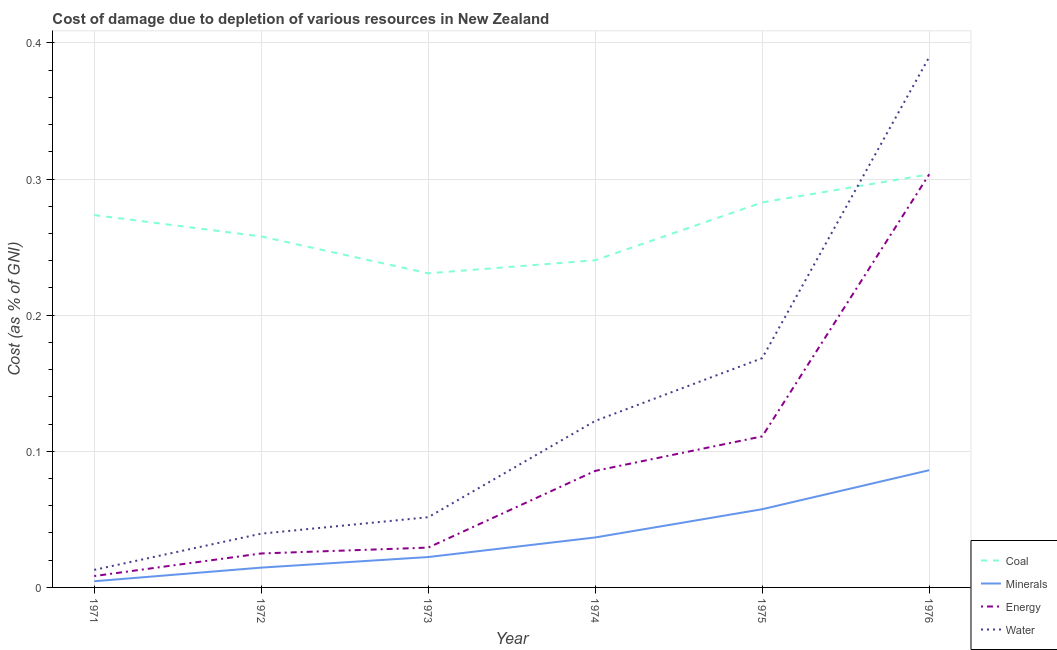Does the line corresponding to cost of damage due to depletion of coal intersect with the line corresponding to cost of damage due to depletion of minerals?
Give a very brief answer. No. Is the number of lines equal to the number of legend labels?
Give a very brief answer. Yes. What is the cost of damage due to depletion of minerals in 1975?
Ensure brevity in your answer.  0.06. Across all years, what is the maximum cost of damage due to depletion of minerals?
Your answer should be very brief. 0.09. Across all years, what is the minimum cost of damage due to depletion of coal?
Provide a short and direct response. 0.23. In which year was the cost of damage due to depletion of minerals maximum?
Keep it short and to the point. 1976. What is the total cost of damage due to depletion of energy in the graph?
Make the answer very short. 0.56. What is the difference between the cost of damage due to depletion of minerals in 1972 and that in 1974?
Your response must be concise. -0.02. What is the difference between the cost of damage due to depletion of water in 1976 and the cost of damage due to depletion of energy in 1972?
Provide a short and direct response. 0.36. What is the average cost of damage due to depletion of energy per year?
Ensure brevity in your answer.  0.09. In the year 1971, what is the difference between the cost of damage due to depletion of coal and cost of damage due to depletion of minerals?
Give a very brief answer. 0.27. In how many years, is the cost of damage due to depletion of water greater than 0.04 %?
Give a very brief answer. 4. What is the ratio of the cost of damage due to depletion of energy in 1974 to that in 1975?
Keep it short and to the point. 0.77. What is the difference between the highest and the second highest cost of damage due to depletion of energy?
Provide a short and direct response. 0.19. What is the difference between the highest and the lowest cost of damage due to depletion of water?
Offer a terse response. 0.38. Is it the case that in every year, the sum of the cost of damage due to depletion of minerals and cost of damage due to depletion of water is greater than the sum of cost of damage due to depletion of coal and cost of damage due to depletion of energy?
Offer a very short reply. No. Is the cost of damage due to depletion of minerals strictly less than the cost of damage due to depletion of coal over the years?
Your answer should be very brief. Yes. Are the values on the major ticks of Y-axis written in scientific E-notation?
Offer a very short reply. No. Does the graph contain any zero values?
Make the answer very short. No. How many legend labels are there?
Keep it short and to the point. 4. How are the legend labels stacked?
Offer a terse response. Vertical. What is the title of the graph?
Make the answer very short. Cost of damage due to depletion of various resources in New Zealand . What is the label or title of the Y-axis?
Ensure brevity in your answer.  Cost (as % of GNI). What is the Cost (as % of GNI) of Coal in 1971?
Provide a short and direct response. 0.27. What is the Cost (as % of GNI) in Minerals in 1971?
Offer a very short reply. 0. What is the Cost (as % of GNI) in Energy in 1971?
Give a very brief answer. 0.01. What is the Cost (as % of GNI) in Water in 1971?
Your answer should be very brief. 0.01. What is the Cost (as % of GNI) in Coal in 1972?
Your answer should be compact. 0.26. What is the Cost (as % of GNI) of Minerals in 1972?
Your answer should be compact. 0.01. What is the Cost (as % of GNI) of Energy in 1972?
Keep it short and to the point. 0.02. What is the Cost (as % of GNI) in Water in 1972?
Your answer should be very brief. 0.04. What is the Cost (as % of GNI) in Coal in 1973?
Your answer should be compact. 0.23. What is the Cost (as % of GNI) in Minerals in 1973?
Give a very brief answer. 0.02. What is the Cost (as % of GNI) in Energy in 1973?
Make the answer very short. 0.03. What is the Cost (as % of GNI) in Water in 1973?
Offer a very short reply. 0.05. What is the Cost (as % of GNI) in Coal in 1974?
Provide a short and direct response. 0.24. What is the Cost (as % of GNI) of Minerals in 1974?
Offer a terse response. 0.04. What is the Cost (as % of GNI) of Energy in 1974?
Make the answer very short. 0.09. What is the Cost (as % of GNI) in Water in 1974?
Ensure brevity in your answer.  0.12. What is the Cost (as % of GNI) in Coal in 1975?
Give a very brief answer. 0.28. What is the Cost (as % of GNI) of Minerals in 1975?
Give a very brief answer. 0.06. What is the Cost (as % of GNI) of Energy in 1975?
Give a very brief answer. 0.11. What is the Cost (as % of GNI) in Water in 1975?
Keep it short and to the point. 0.17. What is the Cost (as % of GNI) of Coal in 1976?
Provide a short and direct response. 0.3. What is the Cost (as % of GNI) of Minerals in 1976?
Your answer should be very brief. 0.09. What is the Cost (as % of GNI) in Energy in 1976?
Offer a very short reply. 0.3. What is the Cost (as % of GNI) in Water in 1976?
Your answer should be very brief. 0.39. Across all years, what is the maximum Cost (as % of GNI) of Coal?
Make the answer very short. 0.3. Across all years, what is the maximum Cost (as % of GNI) in Minerals?
Provide a short and direct response. 0.09. Across all years, what is the maximum Cost (as % of GNI) of Energy?
Make the answer very short. 0.3. Across all years, what is the maximum Cost (as % of GNI) of Water?
Offer a very short reply. 0.39. Across all years, what is the minimum Cost (as % of GNI) in Coal?
Provide a short and direct response. 0.23. Across all years, what is the minimum Cost (as % of GNI) of Minerals?
Offer a terse response. 0. Across all years, what is the minimum Cost (as % of GNI) in Energy?
Keep it short and to the point. 0.01. Across all years, what is the minimum Cost (as % of GNI) of Water?
Provide a succinct answer. 0.01. What is the total Cost (as % of GNI) of Coal in the graph?
Provide a short and direct response. 1.59. What is the total Cost (as % of GNI) in Minerals in the graph?
Give a very brief answer. 0.22. What is the total Cost (as % of GNI) in Energy in the graph?
Provide a succinct answer. 0.56. What is the total Cost (as % of GNI) of Water in the graph?
Offer a terse response. 0.78. What is the difference between the Cost (as % of GNI) in Coal in 1971 and that in 1972?
Offer a very short reply. 0.02. What is the difference between the Cost (as % of GNI) in Minerals in 1971 and that in 1972?
Your answer should be very brief. -0.01. What is the difference between the Cost (as % of GNI) in Energy in 1971 and that in 1972?
Keep it short and to the point. -0.02. What is the difference between the Cost (as % of GNI) of Water in 1971 and that in 1972?
Your response must be concise. -0.03. What is the difference between the Cost (as % of GNI) in Coal in 1971 and that in 1973?
Offer a terse response. 0.04. What is the difference between the Cost (as % of GNI) in Minerals in 1971 and that in 1973?
Make the answer very short. -0.02. What is the difference between the Cost (as % of GNI) in Energy in 1971 and that in 1973?
Offer a very short reply. -0.02. What is the difference between the Cost (as % of GNI) of Water in 1971 and that in 1973?
Offer a very short reply. -0.04. What is the difference between the Cost (as % of GNI) of Coal in 1971 and that in 1974?
Give a very brief answer. 0.03. What is the difference between the Cost (as % of GNI) in Minerals in 1971 and that in 1974?
Keep it short and to the point. -0.03. What is the difference between the Cost (as % of GNI) in Energy in 1971 and that in 1974?
Provide a short and direct response. -0.08. What is the difference between the Cost (as % of GNI) of Water in 1971 and that in 1974?
Provide a succinct answer. -0.11. What is the difference between the Cost (as % of GNI) of Coal in 1971 and that in 1975?
Keep it short and to the point. -0.01. What is the difference between the Cost (as % of GNI) of Minerals in 1971 and that in 1975?
Provide a short and direct response. -0.05. What is the difference between the Cost (as % of GNI) in Energy in 1971 and that in 1975?
Your answer should be very brief. -0.1. What is the difference between the Cost (as % of GNI) of Water in 1971 and that in 1975?
Provide a short and direct response. -0.16. What is the difference between the Cost (as % of GNI) in Coal in 1971 and that in 1976?
Make the answer very short. -0.03. What is the difference between the Cost (as % of GNI) of Minerals in 1971 and that in 1976?
Offer a terse response. -0.08. What is the difference between the Cost (as % of GNI) of Energy in 1971 and that in 1976?
Provide a short and direct response. -0.3. What is the difference between the Cost (as % of GNI) of Water in 1971 and that in 1976?
Give a very brief answer. -0.38. What is the difference between the Cost (as % of GNI) in Coal in 1972 and that in 1973?
Keep it short and to the point. 0.03. What is the difference between the Cost (as % of GNI) of Minerals in 1972 and that in 1973?
Your answer should be compact. -0.01. What is the difference between the Cost (as % of GNI) of Energy in 1972 and that in 1973?
Your response must be concise. -0. What is the difference between the Cost (as % of GNI) of Water in 1972 and that in 1973?
Ensure brevity in your answer.  -0.01. What is the difference between the Cost (as % of GNI) in Coal in 1972 and that in 1974?
Provide a succinct answer. 0.02. What is the difference between the Cost (as % of GNI) in Minerals in 1972 and that in 1974?
Your answer should be very brief. -0.02. What is the difference between the Cost (as % of GNI) in Energy in 1972 and that in 1974?
Your response must be concise. -0.06. What is the difference between the Cost (as % of GNI) in Water in 1972 and that in 1974?
Your answer should be very brief. -0.08. What is the difference between the Cost (as % of GNI) of Coal in 1972 and that in 1975?
Provide a succinct answer. -0.03. What is the difference between the Cost (as % of GNI) of Minerals in 1972 and that in 1975?
Make the answer very short. -0.04. What is the difference between the Cost (as % of GNI) in Energy in 1972 and that in 1975?
Give a very brief answer. -0.09. What is the difference between the Cost (as % of GNI) in Water in 1972 and that in 1975?
Make the answer very short. -0.13. What is the difference between the Cost (as % of GNI) in Coal in 1972 and that in 1976?
Your answer should be compact. -0.05. What is the difference between the Cost (as % of GNI) of Minerals in 1972 and that in 1976?
Offer a terse response. -0.07. What is the difference between the Cost (as % of GNI) in Energy in 1972 and that in 1976?
Make the answer very short. -0.28. What is the difference between the Cost (as % of GNI) of Water in 1972 and that in 1976?
Offer a very short reply. -0.35. What is the difference between the Cost (as % of GNI) in Coal in 1973 and that in 1974?
Your response must be concise. -0.01. What is the difference between the Cost (as % of GNI) of Minerals in 1973 and that in 1974?
Ensure brevity in your answer.  -0.01. What is the difference between the Cost (as % of GNI) of Energy in 1973 and that in 1974?
Your answer should be very brief. -0.06. What is the difference between the Cost (as % of GNI) of Water in 1973 and that in 1974?
Provide a succinct answer. -0.07. What is the difference between the Cost (as % of GNI) of Coal in 1973 and that in 1975?
Provide a short and direct response. -0.05. What is the difference between the Cost (as % of GNI) in Minerals in 1973 and that in 1975?
Ensure brevity in your answer.  -0.04. What is the difference between the Cost (as % of GNI) in Energy in 1973 and that in 1975?
Your answer should be compact. -0.08. What is the difference between the Cost (as % of GNI) in Water in 1973 and that in 1975?
Give a very brief answer. -0.12. What is the difference between the Cost (as % of GNI) in Coal in 1973 and that in 1976?
Make the answer very short. -0.07. What is the difference between the Cost (as % of GNI) of Minerals in 1973 and that in 1976?
Offer a very short reply. -0.06. What is the difference between the Cost (as % of GNI) in Energy in 1973 and that in 1976?
Give a very brief answer. -0.27. What is the difference between the Cost (as % of GNI) in Water in 1973 and that in 1976?
Offer a terse response. -0.34. What is the difference between the Cost (as % of GNI) in Coal in 1974 and that in 1975?
Offer a terse response. -0.04. What is the difference between the Cost (as % of GNI) in Minerals in 1974 and that in 1975?
Offer a very short reply. -0.02. What is the difference between the Cost (as % of GNI) of Energy in 1974 and that in 1975?
Your response must be concise. -0.03. What is the difference between the Cost (as % of GNI) of Water in 1974 and that in 1975?
Your response must be concise. -0.05. What is the difference between the Cost (as % of GNI) of Coal in 1974 and that in 1976?
Make the answer very short. -0.06. What is the difference between the Cost (as % of GNI) in Minerals in 1974 and that in 1976?
Give a very brief answer. -0.05. What is the difference between the Cost (as % of GNI) in Energy in 1974 and that in 1976?
Make the answer very short. -0.22. What is the difference between the Cost (as % of GNI) of Water in 1974 and that in 1976?
Provide a succinct answer. -0.27. What is the difference between the Cost (as % of GNI) of Coal in 1975 and that in 1976?
Provide a short and direct response. -0.02. What is the difference between the Cost (as % of GNI) of Minerals in 1975 and that in 1976?
Your response must be concise. -0.03. What is the difference between the Cost (as % of GNI) in Energy in 1975 and that in 1976?
Provide a succinct answer. -0.19. What is the difference between the Cost (as % of GNI) in Water in 1975 and that in 1976?
Provide a succinct answer. -0.22. What is the difference between the Cost (as % of GNI) in Coal in 1971 and the Cost (as % of GNI) in Minerals in 1972?
Your response must be concise. 0.26. What is the difference between the Cost (as % of GNI) of Coal in 1971 and the Cost (as % of GNI) of Energy in 1972?
Ensure brevity in your answer.  0.25. What is the difference between the Cost (as % of GNI) of Coal in 1971 and the Cost (as % of GNI) of Water in 1972?
Give a very brief answer. 0.23. What is the difference between the Cost (as % of GNI) of Minerals in 1971 and the Cost (as % of GNI) of Energy in 1972?
Provide a short and direct response. -0.02. What is the difference between the Cost (as % of GNI) of Minerals in 1971 and the Cost (as % of GNI) of Water in 1972?
Provide a short and direct response. -0.04. What is the difference between the Cost (as % of GNI) of Energy in 1971 and the Cost (as % of GNI) of Water in 1972?
Your response must be concise. -0.03. What is the difference between the Cost (as % of GNI) in Coal in 1971 and the Cost (as % of GNI) in Minerals in 1973?
Your answer should be compact. 0.25. What is the difference between the Cost (as % of GNI) of Coal in 1971 and the Cost (as % of GNI) of Energy in 1973?
Ensure brevity in your answer.  0.24. What is the difference between the Cost (as % of GNI) in Coal in 1971 and the Cost (as % of GNI) in Water in 1973?
Your answer should be very brief. 0.22. What is the difference between the Cost (as % of GNI) of Minerals in 1971 and the Cost (as % of GNI) of Energy in 1973?
Provide a short and direct response. -0.02. What is the difference between the Cost (as % of GNI) in Minerals in 1971 and the Cost (as % of GNI) in Water in 1973?
Your answer should be very brief. -0.05. What is the difference between the Cost (as % of GNI) in Energy in 1971 and the Cost (as % of GNI) in Water in 1973?
Provide a succinct answer. -0.04. What is the difference between the Cost (as % of GNI) of Coal in 1971 and the Cost (as % of GNI) of Minerals in 1974?
Offer a very short reply. 0.24. What is the difference between the Cost (as % of GNI) of Coal in 1971 and the Cost (as % of GNI) of Energy in 1974?
Offer a very short reply. 0.19. What is the difference between the Cost (as % of GNI) of Coal in 1971 and the Cost (as % of GNI) of Water in 1974?
Provide a short and direct response. 0.15. What is the difference between the Cost (as % of GNI) in Minerals in 1971 and the Cost (as % of GNI) in Energy in 1974?
Your answer should be very brief. -0.08. What is the difference between the Cost (as % of GNI) of Minerals in 1971 and the Cost (as % of GNI) of Water in 1974?
Your response must be concise. -0.12. What is the difference between the Cost (as % of GNI) of Energy in 1971 and the Cost (as % of GNI) of Water in 1974?
Give a very brief answer. -0.11. What is the difference between the Cost (as % of GNI) in Coal in 1971 and the Cost (as % of GNI) in Minerals in 1975?
Keep it short and to the point. 0.22. What is the difference between the Cost (as % of GNI) in Coal in 1971 and the Cost (as % of GNI) in Energy in 1975?
Your answer should be compact. 0.16. What is the difference between the Cost (as % of GNI) in Coal in 1971 and the Cost (as % of GNI) in Water in 1975?
Provide a short and direct response. 0.11. What is the difference between the Cost (as % of GNI) of Minerals in 1971 and the Cost (as % of GNI) of Energy in 1975?
Keep it short and to the point. -0.11. What is the difference between the Cost (as % of GNI) in Minerals in 1971 and the Cost (as % of GNI) in Water in 1975?
Offer a terse response. -0.16. What is the difference between the Cost (as % of GNI) in Energy in 1971 and the Cost (as % of GNI) in Water in 1975?
Provide a succinct answer. -0.16. What is the difference between the Cost (as % of GNI) of Coal in 1971 and the Cost (as % of GNI) of Minerals in 1976?
Ensure brevity in your answer.  0.19. What is the difference between the Cost (as % of GNI) in Coal in 1971 and the Cost (as % of GNI) in Energy in 1976?
Ensure brevity in your answer.  -0.03. What is the difference between the Cost (as % of GNI) of Coal in 1971 and the Cost (as % of GNI) of Water in 1976?
Provide a succinct answer. -0.12. What is the difference between the Cost (as % of GNI) of Minerals in 1971 and the Cost (as % of GNI) of Energy in 1976?
Your answer should be compact. -0.3. What is the difference between the Cost (as % of GNI) in Minerals in 1971 and the Cost (as % of GNI) in Water in 1976?
Provide a succinct answer. -0.39. What is the difference between the Cost (as % of GNI) of Energy in 1971 and the Cost (as % of GNI) of Water in 1976?
Your response must be concise. -0.38. What is the difference between the Cost (as % of GNI) in Coal in 1972 and the Cost (as % of GNI) in Minerals in 1973?
Provide a short and direct response. 0.24. What is the difference between the Cost (as % of GNI) of Coal in 1972 and the Cost (as % of GNI) of Energy in 1973?
Offer a terse response. 0.23. What is the difference between the Cost (as % of GNI) of Coal in 1972 and the Cost (as % of GNI) of Water in 1973?
Your answer should be very brief. 0.21. What is the difference between the Cost (as % of GNI) of Minerals in 1972 and the Cost (as % of GNI) of Energy in 1973?
Provide a short and direct response. -0.01. What is the difference between the Cost (as % of GNI) in Minerals in 1972 and the Cost (as % of GNI) in Water in 1973?
Ensure brevity in your answer.  -0.04. What is the difference between the Cost (as % of GNI) in Energy in 1972 and the Cost (as % of GNI) in Water in 1973?
Your answer should be compact. -0.03. What is the difference between the Cost (as % of GNI) in Coal in 1972 and the Cost (as % of GNI) in Minerals in 1974?
Your answer should be compact. 0.22. What is the difference between the Cost (as % of GNI) of Coal in 1972 and the Cost (as % of GNI) of Energy in 1974?
Ensure brevity in your answer.  0.17. What is the difference between the Cost (as % of GNI) in Coal in 1972 and the Cost (as % of GNI) in Water in 1974?
Your response must be concise. 0.14. What is the difference between the Cost (as % of GNI) in Minerals in 1972 and the Cost (as % of GNI) in Energy in 1974?
Keep it short and to the point. -0.07. What is the difference between the Cost (as % of GNI) of Minerals in 1972 and the Cost (as % of GNI) of Water in 1974?
Offer a very short reply. -0.11. What is the difference between the Cost (as % of GNI) of Energy in 1972 and the Cost (as % of GNI) of Water in 1974?
Give a very brief answer. -0.1. What is the difference between the Cost (as % of GNI) in Coal in 1972 and the Cost (as % of GNI) in Minerals in 1975?
Your answer should be compact. 0.2. What is the difference between the Cost (as % of GNI) of Coal in 1972 and the Cost (as % of GNI) of Energy in 1975?
Keep it short and to the point. 0.15. What is the difference between the Cost (as % of GNI) in Coal in 1972 and the Cost (as % of GNI) in Water in 1975?
Ensure brevity in your answer.  0.09. What is the difference between the Cost (as % of GNI) of Minerals in 1972 and the Cost (as % of GNI) of Energy in 1975?
Your answer should be compact. -0.1. What is the difference between the Cost (as % of GNI) of Minerals in 1972 and the Cost (as % of GNI) of Water in 1975?
Offer a very short reply. -0.15. What is the difference between the Cost (as % of GNI) of Energy in 1972 and the Cost (as % of GNI) of Water in 1975?
Ensure brevity in your answer.  -0.14. What is the difference between the Cost (as % of GNI) of Coal in 1972 and the Cost (as % of GNI) of Minerals in 1976?
Give a very brief answer. 0.17. What is the difference between the Cost (as % of GNI) of Coal in 1972 and the Cost (as % of GNI) of Energy in 1976?
Offer a very short reply. -0.05. What is the difference between the Cost (as % of GNI) in Coal in 1972 and the Cost (as % of GNI) in Water in 1976?
Provide a short and direct response. -0.13. What is the difference between the Cost (as % of GNI) of Minerals in 1972 and the Cost (as % of GNI) of Energy in 1976?
Give a very brief answer. -0.29. What is the difference between the Cost (as % of GNI) of Minerals in 1972 and the Cost (as % of GNI) of Water in 1976?
Keep it short and to the point. -0.38. What is the difference between the Cost (as % of GNI) of Energy in 1972 and the Cost (as % of GNI) of Water in 1976?
Your response must be concise. -0.36. What is the difference between the Cost (as % of GNI) in Coal in 1973 and the Cost (as % of GNI) in Minerals in 1974?
Keep it short and to the point. 0.19. What is the difference between the Cost (as % of GNI) of Coal in 1973 and the Cost (as % of GNI) of Energy in 1974?
Your response must be concise. 0.15. What is the difference between the Cost (as % of GNI) of Coal in 1973 and the Cost (as % of GNI) of Water in 1974?
Offer a very short reply. 0.11. What is the difference between the Cost (as % of GNI) in Minerals in 1973 and the Cost (as % of GNI) in Energy in 1974?
Provide a short and direct response. -0.06. What is the difference between the Cost (as % of GNI) in Energy in 1973 and the Cost (as % of GNI) in Water in 1974?
Ensure brevity in your answer.  -0.09. What is the difference between the Cost (as % of GNI) in Coal in 1973 and the Cost (as % of GNI) in Minerals in 1975?
Keep it short and to the point. 0.17. What is the difference between the Cost (as % of GNI) of Coal in 1973 and the Cost (as % of GNI) of Energy in 1975?
Your answer should be compact. 0.12. What is the difference between the Cost (as % of GNI) of Coal in 1973 and the Cost (as % of GNI) of Water in 1975?
Provide a short and direct response. 0.06. What is the difference between the Cost (as % of GNI) of Minerals in 1973 and the Cost (as % of GNI) of Energy in 1975?
Provide a short and direct response. -0.09. What is the difference between the Cost (as % of GNI) of Minerals in 1973 and the Cost (as % of GNI) of Water in 1975?
Keep it short and to the point. -0.15. What is the difference between the Cost (as % of GNI) of Energy in 1973 and the Cost (as % of GNI) of Water in 1975?
Your response must be concise. -0.14. What is the difference between the Cost (as % of GNI) of Coal in 1973 and the Cost (as % of GNI) of Minerals in 1976?
Ensure brevity in your answer.  0.14. What is the difference between the Cost (as % of GNI) of Coal in 1973 and the Cost (as % of GNI) of Energy in 1976?
Make the answer very short. -0.07. What is the difference between the Cost (as % of GNI) of Coal in 1973 and the Cost (as % of GNI) of Water in 1976?
Provide a succinct answer. -0.16. What is the difference between the Cost (as % of GNI) in Minerals in 1973 and the Cost (as % of GNI) in Energy in 1976?
Your response must be concise. -0.28. What is the difference between the Cost (as % of GNI) of Minerals in 1973 and the Cost (as % of GNI) of Water in 1976?
Offer a terse response. -0.37. What is the difference between the Cost (as % of GNI) of Energy in 1973 and the Cost (as % of GNI) of Water in 1976?
Your answer should be compact. -0.36. What is the difference between the Cost (as % of GNI) of Coal in 1974 and the Cost (as % of GNI) of Minerals in 1975?
Offer a very short reply. 0.18. What is the difference between the Cost (as % of GNI) in Coal in 1974 and the Cost (as % of GNI) in Energy in 1975?
Provide a short and direct response. 0.13. What is the difference between the Cost (as % of GNI) of Coal in 1974 and the Cost (as % of GNI) of Water in 1975?
Provide a succinct answer. 0.07. What is the difference between the Cost (as % of GNI) of Minerals in 1974 and the Cost (as % of GNI) of Energy in 1975?
Provide a short and direct response. -0.07. What is the difference between the Cost (as % of GNI) in Minerals in 1974 and the Cost (as % of GNI) in Water in 1975?
Your answer should be very brief. -0.13. What is the difference between the Cost (as % of GNI) in Energy in 1974 and the Cost (as % of GNI) in Water in 1975?
Your answer should be very brief. -0.08. What is the difference between the Cost (as % of GNI) in Coal in 1974 and the Cost (as % of GNI) in Minerals in 1976?
Keep it short and to the point. 0.15. What is the difference between the Cost (as % of GNI) in Coal in 1974 and the Cost (as % of GNI) in Energy in 1976?
Give a very brief answer. -0.06. What is the difference between the Cost (as % of GNI) of Coal in 1974 and the Cost (as % of GNI) of Water in 1976?
Your response must be concise. -0.15. What is the difference between the Cost (as % of GNI) of Minerals in 1974 and the Cost (as % of GNI) of Energy in 1976?
Your answer should be very brief. -0.27. What is the difference between the Cost (as % of GNI) in Minerals in 1974 and the Cost (as % of GNI) in Water in 1976?
Give a very brief answer. -0.35. What is the difference between the Cost (as % of GNI) in Energy in 1974 and the Cost (as % of GNI) in Water in 1976?
Provide a short and direct response. -0.3. What is the difference between the Cost (as % of GNI) in Coal in 1975 and the Cost (as % of GNI) in Minerals in 1976?
Keep it short and to the point. 0.2. What is the difference between the Cost (as % of GNI) in Coal in 1975 and the Cost (as % of GNI) in Energy in 1976?
Keep it short and to the point. -0.02. What is the difference between the Cost (as % of GNI) of Coal in 1975 and the Cost (as % of GNI) of Water in 1976?
Your answer should be very brief. -0.11. What is the difference between the Cost (as % of GNI) in Minerals in 1975 and the Cost (as % of GNI) in Energy in 1976?
Ensure brevity in your answer.  -0.25. What is the difference between the Cost (as % of GNI) in Minerals in 1975 and the Cost (as % of GNI) in Water in 1976?
Your answer should be compact. -0.33. What is the difference between the Cost (as % of GNI) in Energy in 1975 and the Cost (as % of GNI) in Water in 1976?
Your response must be concise. -0.28. What is the average Cost (as % of GNI) in Coal per year?
Ensure brevity in your answer.  0.26. What is the average Cost (as % of GNI) in Minerals per year?
Provide a succinct answer. 0.04. What is the average Cost (as % of GNI) of Energy per year?
Provide a short and direct response. 0.09. What is the average Cost (as % of GNI) in Water per year?
Make the answer very short. 0.13. In the year 1971, what is the difference between the Cost (as % of GNI) of Coal and Cost (as % of GNI) of Minerals?
Make the answer very short. 0.27. In the year 1971, what is the difference between the Cost (as % of GNI) in Coal and Cost (as % of GNI) in Energy?
Your response must be concise. 0.27. In the year 1971, what is the difference between the Cost (as % of GNI) of Coal and Cost (as % of GNI) of Water?
Make the answer very short. 0.26. In the year 1971, what is the difference between the Cost (as % of GNI) in Minerals and Cost (as % of GNI) in Energy?
Keep it short and to the point. -0. In the year 1971, what is the difference between the Cost (as % of GNI) of Minerals and Cost (as % of GNI) of Water?
Give a very brief answer. -0.01. In the year 1971, what is the difference between the Cost (as % of GNI) in Energy and Cost (as % of GNI) in Water?
Offer a terse response. -0. In the year 1972, what is the difference between the Cost (as % of GNI) in Coal and Cost (as % of GNI) in Minerals?
Your answer should be very brief. 0.24. In the year 1972, what is the difference between the Cost (as % of GNI) of Coal and Cost (as % of GNI) of Energy?
Give a very brief answer. 0.23. In the year 1972, what is the difference between the Cost (as % of GNI) in Coal and Cost (as % of GNI) in Water?
Keep it short and to the point. 0.22. In the year 1972, what is the difference between the Cost (as % of GNI) in Minerals and Cost (as % of GNI) in Energy?
Ensure brevity in your answer.  -0.01. In the year 1972, what is the difference between the Cost (as % of GNI) in Minerals and Cost (as % of GNI) in Water?
Give a very brief answer. -0.02. In the year 1972, what is the difference between the Cost (as % of GNI) in Energy and Cost (as % of GNI) in Water?
Keep it short and to the point. -0.01. In the year 1973, what is the difference between the Cost (as % of GNI) in Coal and Cost (as % of GNI) in Minerals?
Your answer should be compact. 0.21. In the year 1973, what is the difference between the Cost (as % of GNI) in Coal and Cost (as % of GNI) in Energy?
Your response must be concise. 0.2. In the year 1973, what is the difference between the Cost (as % of GNI) of Coal and Cost (as % of GNI) of Water?
Keep it short and to the point. 0.18. In the year 1973, what is the difference between the Cost (as % of GNI) in Minerals and Cost (as % of GNI) in Energy?
Your answer should be very brief. -0.01. In the year 1973, what is the difference between the Cost (as % of GNI) in Minerals and Cost (as % of GNI) in Water?
Ensure brevity in your answer.  -0.03. In the year 1973, what is the difference between the Cost (as % of GNI) in Energy and Cost (as % of GNI) in Water?
Ensure brevity in your answer.  -0.02. In the year 1974, what is the difference between the Cost (as % of GNI) of Coal and Cost (as % of GNI) of Minerals?
Offer a very short reply. 0.2. In the year 1974, what is the difference between the Cost (as % of GNI) in Coal and Cost (as % of GNI) in Energy?
Your answer should be compact. 0.15. In the year 1974, what is the difference between the Cost (as % of GNI) in Coal and Cost (as % of GNI) in Water?
Your response must be concise. 0.12. In the year 1974, what is the difference between the Cost (as % of GNI) in Minerals and Cost (as % of GNI) in Energy?
Offer a terse response. -0.05. In the year 1974, what is the difference between the Cost (as % of GNI) in Minerals and Cost (as % of GNI) in Water?
Your response must be concise. -0.09. In the year 1974, what is the difference between the Cost (as % of GNI) in Energy and Cost (as % of GNI) in Water?
Provide a short and direct response. -0.04. In the year 1975, what is the difference between the Cost (as % of GNI) in Coal and Cost (as % of GNI) in Minerals?
Make the answer very short. 0.23. In the year 1975, what is the difference between the Cost (as % of GNI) in Coal and Cost (as % of GNI) in Energy?
Make the answer very short. 0.17. In the year 1975, what is the difference between the Cost (as % of GNI) in Coal and Cost (as % of GNI) in Water?
Your answer should be very brief. 0.11. In the year 1975, what is the difference between the Cost (as % of GNI) in Minerals and Cost (as % of GNI) in Energy?
Ensure brevity in your answer.  -0.05. In the year 1975, what is the difference between the Cost (as % of GNI) in Minerals and Cost (as % of GNI) in Water?
Your response must be concise. -0.11. In the year 1975, what is the difference between the Cost (as % of GNI) in Energy and Cost (as % of GNI) in Water?
Your answer should be compact. -0.06. In the year 1976, what is the difference between the Cost (as % of GNI) in Coal and Cost (as % of GNI) in Minerals?
Give a very brief answer. 0.22. In the year 1976, what is the difference between the Cost (as % of GNI) of Coal and Cost (as % of GNI) of Water?
Offer a terse response. -0.09. In the year 1976, what is the difference between the Cost (as % of GNI) in Minerals and Cost (as % of GNI) in Energy?
Your answer should be compact. -0.22. In the year 1976, what is the difference between the Cost (as % of GNI) in Minerals and Cost (as % of GNI) in Water?
Provide a succinct answer. -0.3. In the year 1976, what is the difference between the Cost (as % of GNI) in Energy and Cost (as % of GNI) in Water?
Offer a very short reply. -0.09. What is the ratio of the Cost (as % of GNI) of Coal in 1971 to that in 1972?
Your response must be concise. 1.06. What is the ratio of the Cost (as % of GNI) of Minerals in 1971 to that in 1972?
Your answer should be very brief. 0.31. What is the ratio of the Cost (as % of GNI) of Energy in 1971 to that in 1972?
Provide a short and direct response. 0.33. What is the ratio of the Cost (as % of GNI) in Water in 1971 to that in 1972?
Your response must be concise. 0.33. What is the ratio of the Cost (as % of GNI) in Coal in 1971 to that in 1973?
Your response must be concise. 1.19. What is the ratio of the Cost (as % of GNI) of Minerals in 1971 to that in 1973?
Offer a terse response. 0.2. What is the ratio of the Cost (as % of GNI) in Energy in 1971 to that in 1973?
Offer a very short reply. 0.29. What is the ratio of the Cost (as % of GNI) in Coal in 1971 to that in 1974?
Your answer should be compact. 1.14. What is the ratio of the Cost (as % of GNI) in Minerals in 1971 to that in 1974?
Offer a very short reply. 0.12. What is the ratio of the Cost (as % of GNI) in Energy in 1971 to that in 1974?
Your response must be concise. 0.1. What is the ratio of the Cost (as % of GNI) in Water in 1971 to that in 1974?
Provide a short and direct response. 0.11. What is the ratio of the Cost (as % of GNI) of Minerals in 1971 to that in 1975?
Provide a short and direct response. 0.08. What is the ratio of the Cost (as % of GNI) in Energy in 1971 to that in 1975?
Your answer should be very brief. 0.08. What is the ratio of the Cost (as % of GNI) of Water in 1971 to that in 1975?
Make the answer very short. 0.08. What is the ratio of the Cost (as % of GNI) in Coal in 1971 to that in 1976?
Give a very brief answer. 0.9. What is the ratio of the Cost (as % of GNI) of Minerals in 1971 to that in 1976?
Ensure brevity in your answer.  0.05. What is the ratio of the Cost (as % of GNI) of Energy in 1971 to that in 1976?
Your answer should be very brief. 0.03. What is the ratio of the Cost (as % of GNI) of Water in 1971 to that in 1976?
Provide a short and direct response. 0.03. What is the ratio of the Cost (as % of GNI) of Coal in 1972 to that in 1973?
Your response must be concise. 1.12. What is the ratio of the Cost (as % of GNI) in Minerals in 1972 to that in 1973?
Provide a short and direct response. 0.65. What is the ratio of the Cost (as % of GNI) of Energy in 1972 to that in 1973?
Offer a very short reply. 0.85. What is the ratio of the Cost (as % of GNI) of Water in 1972 to that in 1973?
Ensure brevity in your answer.  0.77. What is the ratio of the Cost (as % of GNI) of Coal in 1972 to that in 1974?
Offer a terse response. 1.07. What is the ratio of the Cost (as % of GNI) of Minerals in 1972 to that in 1974?
Your answer should be very brief. 0.4. What is the ratio of the Cost (as % of GNI) in Energy in 1972 to that in 1974?
Keep it short and to the point. 0.29. What is the ratio of the Cost (as % of GNI) in Water in 1972 to that in 1974?
Keep it short and to the point. 0.32. What is the ratio of the Cost (as % of GNI) in Coal in 1972 to that in 1975?
Offer a very short reply. 0.91. What is the ratio of the Cost (as % of GNI) in Minerals in 1972 to that in 1975?
Provide a succinct answer. 0.25. What is the ratio of the Cost (as % of GNI) in Energy in 1972 to that in 1975?
Ensure brevity in your answer.  0.22. What is the ratio of the Cost (as % of GNI) of Water in 1972 to that in 1975?
Offer a terse response. 0.23. What is the ratio of the Cost (as % of GNI) in Coal in 1972 to that in 1976?
Your answer should be very brief. 0.85. What is the ratio of the Cost (as % of GNI) of Minerals in 1972 to that in 1976?
Provide a succinct answer. 0.17. What is the ratio of the Cost (as % of GNI) in Energy in 1972 to that in 1976?
Offer a terse response. 0.08. What is the ratio of the Cost (as % of GNI) of Water in 1972 to that in 1976?
Ensure brevity in your answer.  0.1. What is the ratio of the Cost (as % of GNI) of Coal in 1973 to that in 1974?
Your response must be concise. 0.96. What is the ratio of the Cost (as % of GNI) in Minerals in 1973 to that in 1974?
Offer a very short reply. 0.61. What is the ratio of the Cost (as % of GNI) in Energy in 1973 to that in 1974?
Your response must be concise. 0.34. What is the ratio of the Cost (as % of GNI) of Water in 1973 to that in 1974?
Your response must be concise. 0.42. What is the ratio of the Cost (as % of GNI) of Coal in 1973 to that in 1975?
Give a very brief answer. 0.82. What is the ratio of the Cost (as % of GNI) in Minerals in 1973 to that in 1975?
Offer a terse response. 0.39. What is the ratio of the Cost (as % of GNI) of Energy in 1973 to that in 1975?
Offer a very short reply. 0.26. What is the ratio of the Cost (as % of GNI) of Water in 1973 to that in 1975?
Offer a very short reply. 0.31. What is the ratio of the Cost (as % of GNI) of Coal in 1973 to that in 1976?
Ensure brevity in your answer.  0.76. What is the ratio of the Cost (as % of GNI) in Minerals in 1973 to that in 1976?
Provide a succinct answer. 0.26. What is the ratio of the Cost (as % of GNI) in Energy in 1973 to that in 1976?
Provide a succinct answer. 0.1. What is the ratio of the Cost (as % of GNI) in Water in 1973 to that in 1976?
Your answer should be compact. 0.13. What is the ratio of the Cost (as % of GNI) in Coal in 1974 to that in 1975?
Your answer should be very brief. 0.85. What is the ratio of the Cost (as % of GNI) in Minerals in 1974 to that in 1975?
Your answer should be compact. 0.64. What is the ratio of the Cost (as % of GNI) in Energy in 1974 to that in 1975?
Provide a succinct answer. 0.77. What is the ratio of the Cost (as % of GNI) of Water in 1974 to that in 1975?
Make the answer very short. 0.73. What is the ratio of the Cost (as % of GNI) of Coal in 1974 to that in 1976?
Your answer should be compact. 0.79. What is the ratio of the Cost (as % of GNI) in Minerals in 1974 to that in 1976?
Offer a terse response. 0.43. What is the ratio of the Cost (as % of GNI) in Energy in 1974 to that in 1976?
Ensure brevity in your answer.  0.28. What is the ratio of the Cost (as % of GNI) in Water in 1974 to that in 1976?
Ensure brevity in your answer.  0.31. What is the ratio of the Cost (as % of GNI) of Coal in 1975 to that in 1976?
Keep it short and to the point. 0.93. What is the ratio of the Cost (as % of GNI) in Minerals in 1975 to that in 1976?
Ensure brevity in your answer.  0.67. What is the ratio of the Cost (as % of GNI) in Energy in 1975 to that in 1976?
Offer a terse response. 0.37. What is the ratio of the Cost (as % of GNI) in Water in 1975 to that in 1976?
Give a very brief answer. 0.43. What is the difference between the highest and the second highest Cost (as % of GNI) of Coal?
Give a very brief answer. 0.02. What is the difference between the highest and the second highest Cost (as % of GNI) in Minerals?
Provide a succinct answer. 0.03. What is the difference between the highest and the second highest Cost (as % of GNI) in Energy?
Offer a very short reply. 0.19. What is the difference between the highest and the second highest Cost (as % of GNI) of Water?
Your answer should be compact. 0.22. What is the difference between the highest and the lowest Cost (as % of GNI) in Coal?
Your answer should be very brief. 0.07. What is the difference between the highest and the lowest Cost (as % of GNI) of Minerals?
Offer a terse response. 0.08. What is the difference between the highest and the lowest Cost (as % of GNI) in Energy?
Ensure brevity in your answer.  0.3. What is the difference between the highest and the lowest Cost (as % of GNI) in Water?
Offer a very short reply. 0.38. 